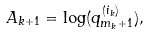Convert formula to latex. <formula><loc_0><loc_0><loc_500><loc_500>A _ { k + 1 } = \log ( q _ { m _ { k } + 1 } ^ { ( i _ { k } ) } ) ,</formula> 